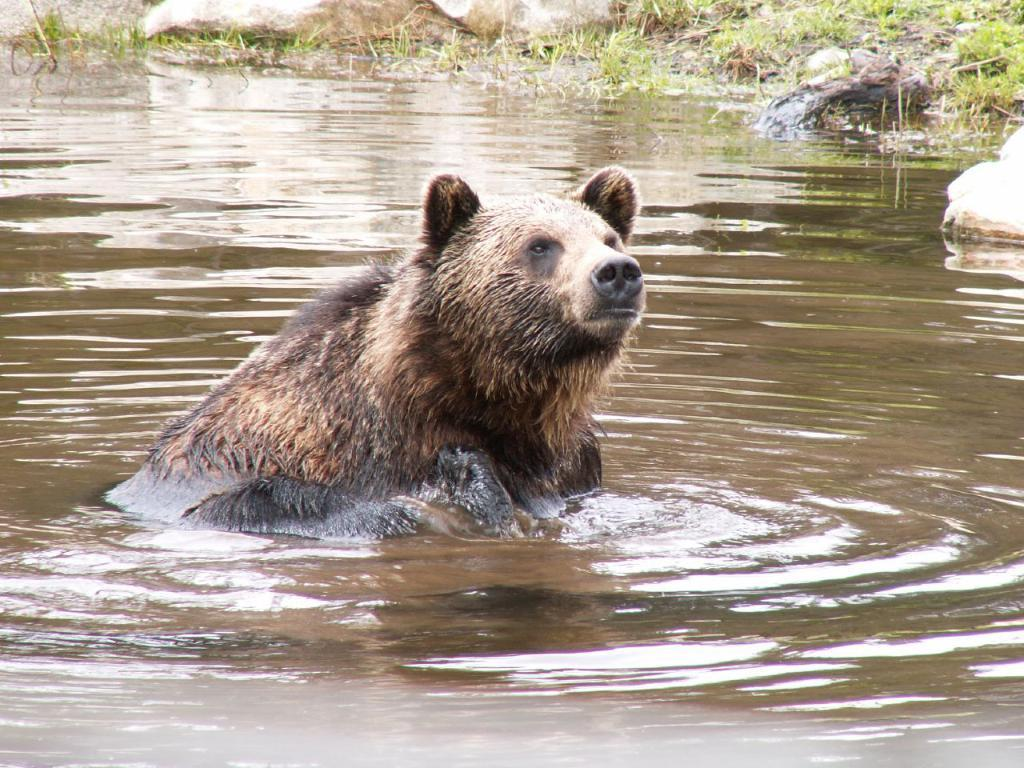What is the primary element in the image? There is water in the image. What animal can be seen in the water? There is a bear in the water. What type of terrain is visible in the background of the image? There are rocks and grass in the background of the image. What type of insurance does the bear have for swimming in the water? There is no mention of insurance in the image, and bears do not require insurance for swimming. 